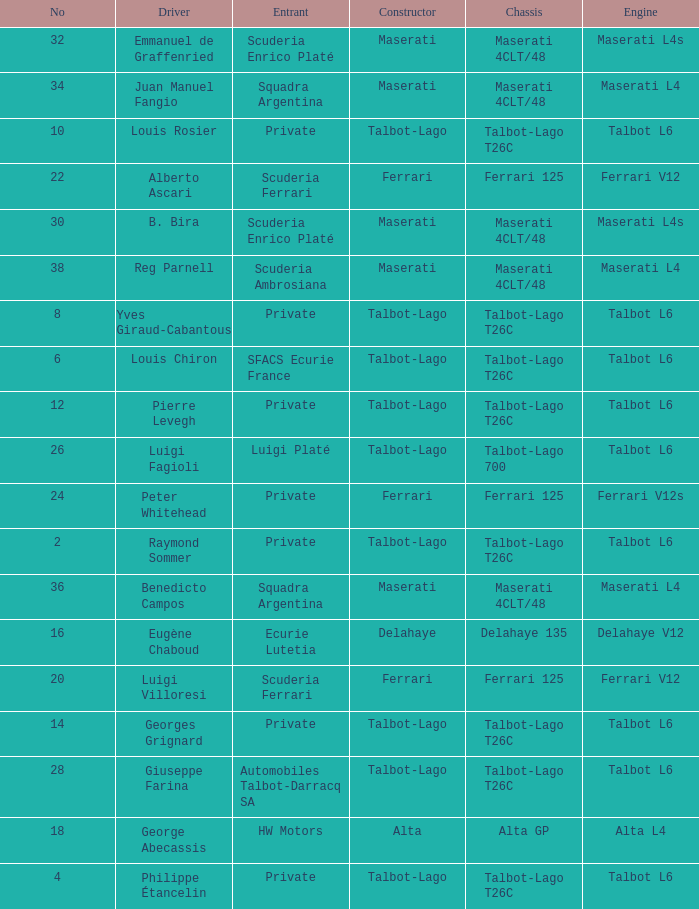Name the constructor for b. bira Maserati. 